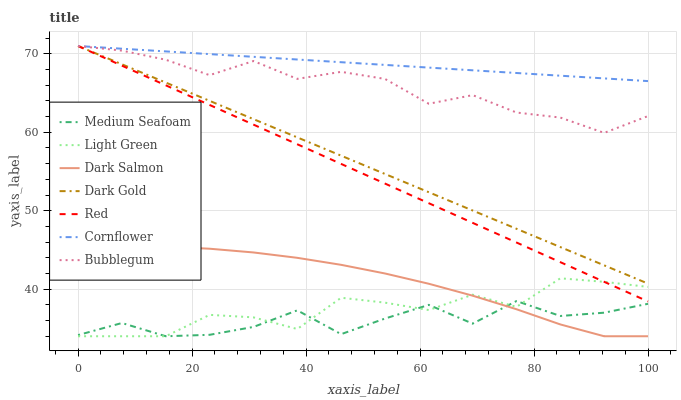Does Medium Seafoam have the minimum area under the curve?
Answer yes or no. Yes. Does Cornflower have the maximum area under the curve?
Answer yes or no. Yes. Does Dark Gold have the minimum area under the curve?
Answer yes or no. No. Does Dark Gold have the maximum area under the curve?
Answer yes or no. No. Is Red the smoothest?
Answer yes or no. Yes. Is Medium Seafoam the roughest?
Answer yes or no. Yes. Is Dark Gold the smoothest?
Answer yes or no. No. Is Dark Gold the roughest?
Answer yes or no. No. Does Dark Gold have the lowest value?
Answer yes or no. No. Does Red have the highest value?
Answer yes or no. Yes. Does Dark Salmon have the highest value?
Answer yes or no. No. Is Medium Seafoam less than Bubblegum?
Answer yes or no. Yes. Is Bubblegum greater than Medium Seafoam?
Answer yes or no. Yes. Does Light Green intersect Red?
Answer yes or no. Yes. Is Light Green less than Red?
Answer yes or no. No. Is Light Green greater than Red?
Answer yes or no. No. Does Medium Seafoam intersect Bubblegum?
Answer yes or no. No. 